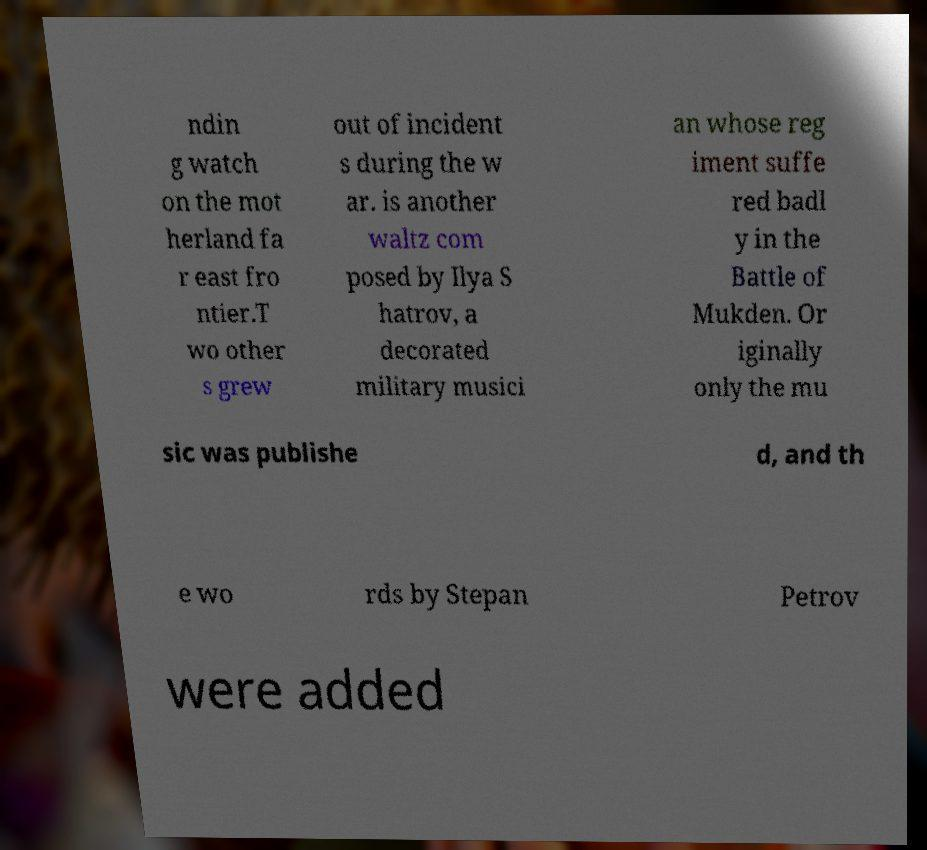I need the written content from this picture converted into text. Can you do that? ndin g watch on the mot herland fa r east fro ntier.T wo other s grew out of incident s during the w ar. is another waltz com posed by Ilya S hatrov, a decorated military musici an whose reg iment suffe red badl y in the Battle of Mukden. Or iginally only the mu sic was publishe d, and th e wo rds by Stepan Petrov were added 